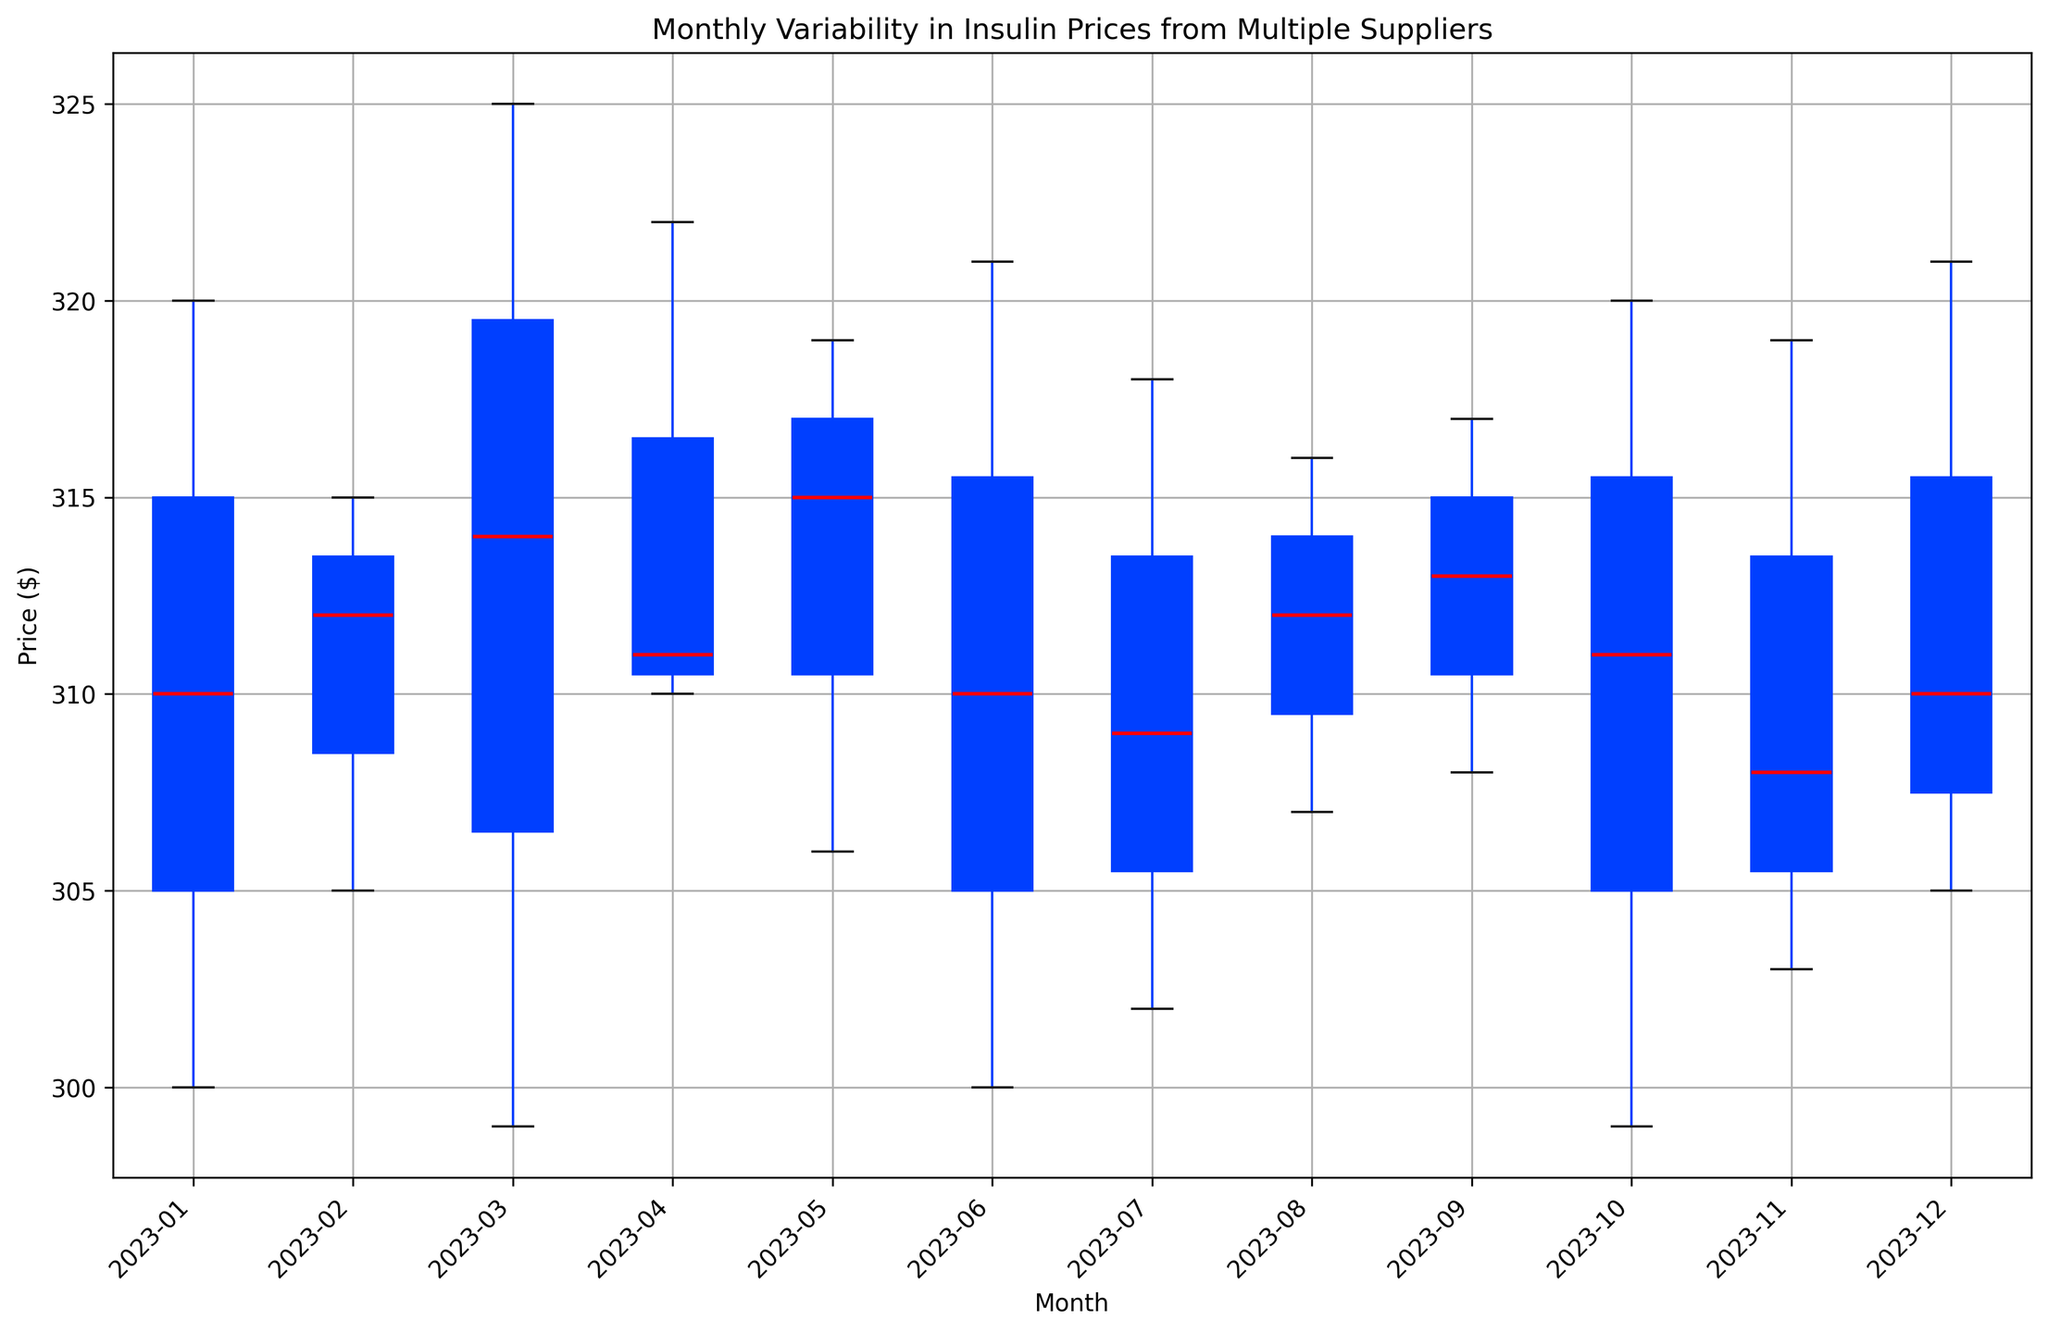What is the highest median insulin price in any month? Look at the boxes and find the median line inside each box. The highest median price can be observed from the placement of these lines.
Answer: 315 Which month shows the lowest median insulin price? Look at the median lines inside the boxes for each month and compare their positions. The lowest median insulin price is found in January.
Answer: January Is the variability in insulin prices greater in February or October? Observe the length of the boxes (interquartile range) for February and October. A longer box indicates greater variability.
Answer: February How does the median insulin price change from January to December? Look at the position of the median lines in January and compare it to December. The change in position shows a small increase.
Answer: Increases slightly Are there any months where the interquartile range (IQR) is particularly narrow or wide? Specify them. The IQR is represented by the height of the boxes. Identify the months with significantly tall or short boxes. March has a wide IQR and November has a narrow IQR.
Answer: March (wide), November (narrow) Which month has the highest variability in insulin prices? Identify the boxes with the greatest height, indicating the month with the highest variability.
Answer: March How does the median insulin price in July compare to that in August? Compare the median lines inside the boxes for July and August. The median price in July is slightly lower than in August.
Answer: Slightly lower In which months are the median insulin prices equal to or less than $305? Examine the positions of the median lines and identify the months that fit the criterion. January, March, April, June, October, and November have medians equal to or less than $305.
Answer: January, March, April, June, October, November Was there any month with an evident outlier? If so, identify the month and supply. An outlier would be represented as a dot outside the whiskers of the boxplot. No evident outliers are present in any month.
Answer: None 